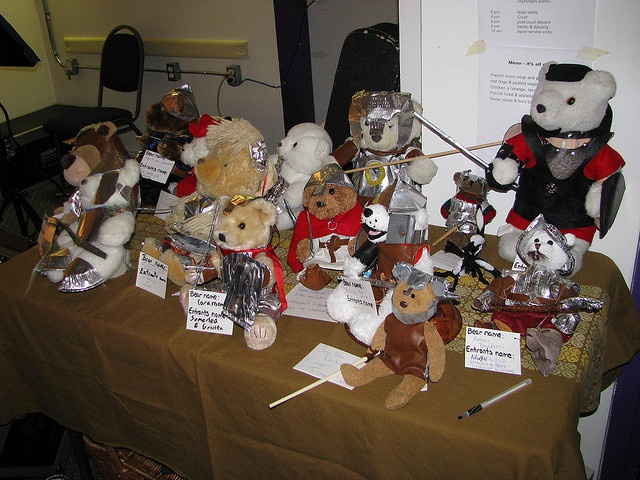Describe the objects in this image and their specific colors. I can see teddy bear in olive, black, darkgray, gray, and maroon tones, teddy bear in olive, tan, black, gray, and darkgray tones, teddy bear in olive, maroon, gray, and tan tones, teddy bear in olive, darkgray, gray, black, and maroon tones, and teddy bear in olive, maroon, gray, black, and darkgray tones in this image. 